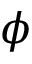<formula> <loc_0><loc_0><loc_500><loc_500>\phi</formula> 